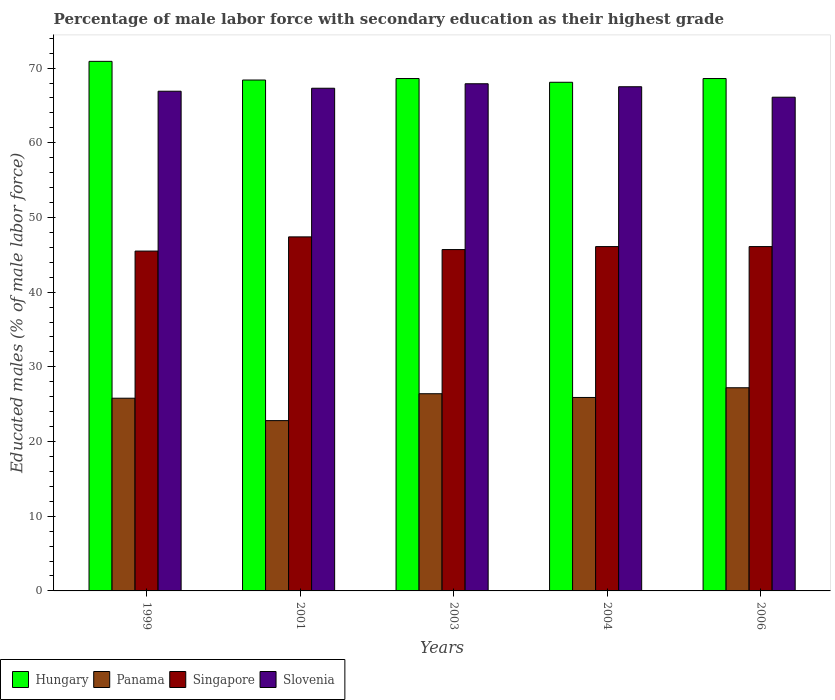How many groups of bars are there?
Keep it short and to the point. 5. Are the number of bars on each tick of the X-axis equal?
Offer a very short reply. Yes. How many bars are there on the 4th tick from the right?
Keep it short and to the point. 4. In how many cases, is the number of bars for a given year not equal to the number of legend labels?
Your answer should be compact. 0. What is the percentage of male labor force with secondary education in Panama in 2001?
Your response must be concise. 22.8. Across all years, what is the maximum percentage of male labor force with secondary education in Hungary?
Ensure brevity in your answer.  70.9. Across all years, what is the minimum percentage of male labor force with secondary education in Singapore?
Provide a succinct answer. 45.5. What is the total percentage of male labor force with secondary education in Singapore in the graph?
Keep it short and to the point. 230.8. What is the difference between the percentage of male labor force with secondary education in Panama in 2001 and that in 2004?
Your response must be concise. -3.1. What is the difference between the percentage of male labor force with secondary education in Slovenia in 1999 and the percentage of male labor force with secondary education in Hungary in 2004?
Give a very brief answer. -1.2. What is the average percentage of male labor force with secondary education in Hungary per year?
Ensure brevity in your answer.  68.92. In the year 2004, what is the difference between the percentage of male labor force with secondary education in Panama and percentage of male labor force with secondary education in Hungary?
Give a very brief answer. -42.2. In how many years, is the percentage of male labor force with secondary education in Panama greater than 18 %?
Provide a short and direct response. 5. What is the ratio of the percentage of male labor force with secondary education in Slovenia in 2004 to that in 2006?
Make the answer very short. 1.02. What is the difference between the highest and the second highest percentage of male labor force with secondary education in Slovenia?
Provide a short and direct response. 0.4. What is the difference between the highest and the lowest percentage of male labor force with secondary education in Hungary?
Give a very brief answer. 2.8. In how many years, is the percentage of male labor force with secondary education in Hungary greater than the average percentage of male labor force with secondary education in Hungary taken over all years?
Make the answer very short. 1. Is the sum of the percentage of male labor force with secondary education in Hungary in 1999 and 2006 greater than the maximum percentage of male labor force with secondary education in Singapore across all years?
Make the answer very short. Yes. What does the 1st bar from the left in 2003 represents?
Your response must be concise. Hungary. What does the 3rd bar from the right in 2003 represents?
Offer a very short reply. Panama. Is it the case that in every year, the sum of the percentage of male labor force with secondary education in Panama and percentage of male labor force with secondary education in Singapore is greater than the percentage of male labor force with secondary education in Slovenia?
Provide a succinct answer. Yes. How many bars are there?
Provide a short and direct response. 20. Are all the bars in the graph horizontal?
Your answer should be compact. No. How many years are there in the graph?
Offer a very short reply. 5. Does the graph contain any zero values?
Your response must be concise. No. Where does the legend appear in the graph?
Offer a very short reply. Bottom left. What is the title of the graph?
Offer a terse response. Percentage of male labor force with secondary education as their highest grade. What is the label or title of the Y-axis?
Your answer should be very brief. Educated males (% of male labor force). What is the Educated males (% of male labor force) of Hungary in 1999?
Ensure brevity in your answer.  70.9. What is the Educated males (% of male labor force) in Panama in 1999?
Offer a terse response. 25.8. What is the Educated males (% of male labor force) in Singapore in 1999?
Offer a terse response. 45.5. What is the Educated males (% of male labor force) in Slovenia in 1999?
Make the answer very short. 66.9. What is the Educated males (% of male labor force) of Hungary in 2001?
Offer a very short reply. 68.4. What is the Educated males (% of male labor force) in Panama in 2001?
Give a very brief answer. 22.8. What is the Educated males (% of male labor force) in Singapore in 2001?
Offer a terse response. 47.4. What is the Educated males (% of male labor force) in Slovenia in 2001?
Keep it short and to the point. 67.3. What is the Educated males (% of male labor force) in Hungary in 2003?
Your answer should be compact. 68.6. What is the Educated males (% of male labor force) in Panama in 2003?
Your response must be concise. 26.4. What is the Educated males (% of male labor force) of Singapore in 2003?
Give a very brief answer. 45.7. What is the Educated males (% of male labor force) in Slovenia in 2003?
Provide a short and direct response. 67.9. What is the Educated males (% of male labor force) in Hungary in 2004?
Your answer should be very brief. 68.1. What is the Educated males (% of male labor force) in Panama in 2004?
Give a very brief answer. 25.9. What is the Educated males (% of male labor force) in Singapore in 2004?
Provide a succinct answer. 46.1. What is the Educated males (% of male labor force) in Slovenia in 2004?
Provide a short and direct response. 67.5. What is the Educated males (% of male labor force) in Hungary in 2006?
Offer a very short reply. 68.6. What is the Educated males (% of male labor force) in Panama in 2006?
Offer a terse response. 27.2. What is the Educated males (% of male labor force) in Singapore in 2006?
Your answer should be compact. 46.1. What is the Educated males (% of male labor force) in Slovenia in 2006?
Your response must be concise. 66.1. Across all years, what is the maximum Educated males (% of male labor force) of Hungary?
Provide a succinct answer. 70.9. Across all years, what is the maximum Educated males (% of male labor force) in Panama?
Provide a short and direct response. 27.2. Across all years, what is the maximum Educated males (% of male labor force) in Singapore?
Offer a very short reply. 47.4. Across all years, what is the maximum Educated males (% of male labor force) of Slovenia?
Provide a short and direct response. 67.9. Across all years, what is the minimum Educated males (% of male labor force) of Hungary?
Your answer should be very brief. 68.1. Across all years, what is the minimum Educated males (% of male labor force) of Panama?
Provide a short and direct response. 22.8. Across all years, what is the minimum Educated males (% of male labor force) in Singapore?
Ensure brevity in your answer.  45.5. Across all years, what is the minimum Educated males (% of male labor force) of Slovenia?
Offer a terse response. 66.1. What is the total Educated males (% of male labor force) of Hungary in the graph?
Your answer should be compact. 344.6. What is the total Educated males (% of male labor force) in Panama in the graph?
Your answer should be very brief. 128.1. What is the total Educated males (% of male labor force) of Singapore in the graph?
Ensure brevity in your answer.  230.8. What is the total Educated males (% of male labor force) in Slovenia in the graph?
Keep it short and to the point. 335.7. What is the difference between the Educated males (% of male labor force) of Hungary in 1999 and that in 2001?
Your response must be concise. 2.5. What is the difference between the Educated males (% of male labor force) in Singapore in 1999 and that in 2001?
Your response must be concise. -1.9. What is the difference between the Educated males (% of male labor force) in Panama in 1999 and that in 2003?
Your answer should be very brief. -0.6. What is the difference between the Educated males (% of male labor force) in Singapore in 1999 and that in 2003?
Give a very brief answer. -0.2. What is the difference between the Educated males (% of male labor force) of Hungary in 1999 and that in 2004?
Provide a short and direct response. 2.8. What is the difference between the Educated males (% of male labor force) of Panama in 1999 and that in 2004?
Offer a very short reply. -0.1. What is the difference between the Educated males (% of male labor force) of Panama in 1999 and that in 2006?
Keep it short and to the point. -1.4. What is the difference between the Educated males (% of male labor force) of Singapore in 1999 and that in 2006?
Your answer should be very brief. -0.6. What is the difference between the Educated males (% of male labor force) in Slovenia in 1999 and that in 2006?
Ensure brevity in your answer.  0.8. What is the difference between the Educated males (% of male labor force) of Panama in 2001 and that in 2003?
Give a very brief answer. -3.6. What is the difference between the Educated males (% of male labor force) in Singapore in 2001 and that in 2003?
Offer a very short reply. 1.7. What is the difference between the Educated males (% of male labor force) in Panama in 2001 and that in 2004?
Make the answer very short. -3.1. What is the difference between the Educated males (% of male labor force) in Singapore in 2001 and that in 2004?
Provide a short and direct response. 1.3. What is the difference between the Educated males (% of male labor force) of Slovenia in 2001 and that in 2004?
Make the answer very short. -0.2. What is the difference between the Educated males (% of male labor force) in Hungary in 2001 and that in 2006?
Your response must be concise. -0.2. What is the difference between the Educated males (% of male labor force) in Panama in 2001 and that in 2006?
Your answer should be compact. -4.4. What is the difference between the Educated males (% of male labor force) of Slovenia in 2001 and that in 2006?
Provide a succinct answer. 1.2. What is the difference between the Educated males (% of male labor force) in Panama in 2003 and that in 2004?
Your response must be concise. 0.5. What is the difference between the Educated males (% of male labor force) of Singapore in 2003 and that in 2004?
Your answer should be compact. -0.4. What is the difference between the Educated males (% of male labor force) in Panama in 2003 and that in 2006?
Offer a very short reply. -0.8. What is the difference between the Educated males (% of male labor force) of Singapore in 2003 and that in 2006?
Your response must be concise. -0.4. What is the difference between the Educated males (% of male labor force) of Slovenia in 2003 and that in 2006?
Your answer should be very brief. 1.8. What is the difference between the Educated males (% of male labor force) in Panama in 2004 and that in 2006?
Offer a very short reply. -1.3. What is the difference between the Educated males (% of male labor force) in Hungary in 1999 and the Educated males (% of male labor force) in Panama in 2001?
Provide a short and direct response. 48.1. What is the difference between the Educated males (% of male labor force) in Hungary in 1999 and the Educated males (% of male labor force) in Singapore in 2001?
Your answer should be very brief. 23.5. What is the difference between the Educated males (% of male labor force) of Hungary in 1999 and the Educated males (% of male labor force) of Slovenia in 2001?
Offer a terse response. 3.6. What is the difference between the Educated males (% of male labor force) in Panama in 1999 and the Educated males (% of male labor force) in Singapore in 2001?
Provide a succinct answer. -21.6. What is the difference between the Educated males (% of male labor force) of Panama in 1999 and the Educated males (% of male labor force) of Slovenia in 2001?
Your response must be concise. -41.5. What is the difference between the Educated males (% of male labor force) in Singapore in 1999 and the Educated males (% of male labor force) in Slovenia in 2001?
Your response must be concise. -21.8. What is the difference between the Educated males (% of male labor force) in Hungary in 1999 and the Educated males (% of male labor force) in Panama in 2003?
Your response must be concise. 44.5. What is the difference between the Educated males (% of male labor force) of Hungary in 1999 and the Educated males (% of male labor force) of Singapore in 2003?
Ensure brevity in your answer.  25.2. What is the difference between the Educated males (% of male labor force) of Hungary in 1999 and the Educated males (% of male labor force) of Slovenia in 2003?
Make the answer very short. 3. What is the difference between the Educated males (% of male labor force) in Panama in 1999 and the Educated males (% of male labor force) in Singapore in 2003?
Provide a short and direct response. -19.9. What is the difference between the Educated males (% of male labor force) in Panama in 1999 and the Educated males (% of male labor force) in Slovenia in 2003?
Your answer should be very brief. -42.1. What is the difference between the Educated males (% of male labor force) in Singapore in 1999 and the Educated males (% of male labor force) in Slovenia in 2003?
Keep it short and to the point. -22.4. What is the difference between the Educated males (% of male labor force) of Hungary in 1999 and the Educated males (% of male labor force) of Singapore in 2004?
Your answer should be very brief. 24.8. What is the difference between the Educated males (% of male labor force) of Hungary in 1999 and the Educated males (% of male labor force) of Slovenia in 2004?
Give a very brief answer. 3.4. What is the difference between the Educated males (% of male labor force) of Panama in 1999 and the Educated males (% of male labor force) of Singapore in 2004?
Offer a very short reply. -20.3. What is the difference between the Educated males (% of male labor force) in Panama in 1999 and the Educated males (% of male labor force) in Slovenia in 2004?
Give a very brief answer. -41.7. What is the difference between the Educated males (% of male labor force) of Singapore in 1999 and the Educated males (% of male labor force) of Slovenia in 2004?
Ensure brevity in your answer.  -22. What is the difference between the Educated males (% of male labor force) of Hungary in 1999 and the Educated males (% of male labor force) of Panama in 2006?
Provide a short and direct response. 43.7. What is the difference between the Educated males (% of male labor force) of Hungary in 1999 and the Educated males (% of male labor force) of Singapore in 2006?
Offer a terse response. 24.8. What is the difference between the Educated males (% of male labor force) of Panama in 1999 and the Educated males (% of male labor force) of Singapore in 2006?
Offer a very short reply. -20.3. What is the difference between the Educated males (% of male labor force) of Panama in 1999 and the Educated males (% of male labor force) of Slovenia in 2006?
Keep it short and to the point. -40.3. What is the difference between the Educated males (% of male labor force) of Singapore in 1999 and the Educated males (% of male labor force) of Slovenia in 2006?
Provide a succinct answer. -20.6. What is the difference between the Educated males (% of male labor force) in Hungary in 2001 and the Educated males (% of male labor force) in Panama in 2003?
Your answer should be compact. 42. What is the difference between the Educated males (% of male labor force) of Hungary in 2001 and the Educated males (% of male labor force) of Singapore in 2003?
Your answer should be very brief. 22.7. What is the difference between the Educated males (% of male labor force) in Panama in 2001 and the Educated males (% of male labor force) in Singapore in 2003?
Provide a short and direct response. -22.9. What is the difference between the Educated males (% of male labor force) in Panama in 2001 and the Educated males (% of male labor force) in Slovenia in 2003?
Your response must be concise. -45.1. What is the difference between the Educated males (% of male labor force) of Singapore in 2001 and the Educated males (% of male labor force) of Slovenia in 2003?
Provide a short and direct response. -20.5. What is the difference between the Educated males (% of male labor force) in Hungary in 2001 and the Educated males (% of male labor force) in Panama in 2004?
Provide a succinct answer. 42.5. What is the difference between the Educated males (% of male labor force) of Hungary in 2001 and the Educated males (% of male labor force) of Singapore in 2004?
Offer a very short reply. 22.3. What is the difference between the Educated males (% of male labor force) of Hungary in 2001 and the Educated males (% of male labor force) of Slovenia in 2004?
Provide a succinct answer. 0.9. What is the difference between the Educated males (% of male labor force) in Panama in 2001 and the Educated males (% of male labor force) in Singapore in 2004?
Your answer should be compact. -23.3. What is the difference between the Educated males (% of male labor force) in Panama in 2001 and the Educated males (% of male labor force) in Slovenia in 2004?
Your answer should be compact. -44.7. What is the difference between the Educated males (% of male labor force) in Singapore in 2001 and the Educated males (% of male labor force) in Slovenia in 2004?
Keep it short and to the point. -20.1. What is the difference between the Educated males (% of male labor force) of Hungary in 2001 and the Educated males (% of male labor force) of Panama in 2006?
Make the answer very short. 41.2. What is the difference between the Educated males (% of male labor force) of Hungary in 2001 and the Educated males (% of male labor force) of Singapore in 2006?
Ensure brevity in your answer.  22.3. What is the difference between the Educated males (% of male labor force) in Hungary in 2001 and the Educated males (% of male labor force) in Slovenia in 2006?
Your response must be concise. 2.3. What is the difference between the Educated males (% of male labor force) in Panama in 2001 and the Educated males (% of male labor force) in Singapore in 2006?
Provide a short and direct response. -23.3. What is the difference between the Educated males (% of male labor force) of Panama in 2001 and the Educated males (% of male labor force) of Slovenia in 2006?
Your response must be concise. -43.3. What is the difference between the Educated males (% of male labor force) in Singapore in 2001 and the Educated males (% of male labor force) in Slovenia in 2006?
Your answer should be very brief. -18.7. What is the difference between the Educated males (% of male labor force) of Hungary in 2003 and the Educated males (% of male labor force) of Panama in 2004?
Provide a short and direct response. 42.7. What is the difference between the Educated males (% of male labor force) of Hungary in 2003 and the Educated males (% of male labor force) of Singapore in 2004?
Your answer should be compact. 22.5. What is the difference between the Educated males (% of male labor force) in Panama in 2003 and the Educated males (% of male labor force) in Singapore in 2004?
Offer a terse response. -19.7. What is the difference between the Educated males (% of male labor force) in Panama in 2003 and the Educated males (% of male labor force) in Slovenia in 2004?
Ensure brevity in your answer.  -41.1. What is the difference between the Educated males (% of male labor force) in Singapore in 2003 and the Educated males (% of male labor force) in Slovenia in 2004?
Keep it short and to the point. -21.8. What is the difference between the Educated males (% of male labor force) in Hungary in 2003 and the Educated males (% of male labor force) in Panama in 2006?
Ensure brevity in your answer.  41.4. What is the difference between the Educated males (% of male labor force) in Hungary in 2003 and the Educated males (% of male labor force) in Singapore in 2006?
Your response must be concise. 22.5. What is the difference between the Educated males (% of male labor force) in Panama in 2003 and the Educated males (% of male labor force) in Singapore in 2006?
Offer a terse response. -19.7. What is the difference between the Educated males (% of male labor force) in Panama in 2003 and the Educated males (% of male labor force) in Slovenia in 2006?
Make the answer very short. -39.7. What is the difference between the Educated males (% of male labor force) in Singapore in 2003 and the Educated males (% of male labor force) in Slovenia in 2006?
Offer a terse response. -20.4. What is the difference between the Educated males (% of male labor force) of Hungary in 2004 and the Educated males (% of male labor force) of Panama in 2006?
Your response must be concise. 40.9. What is the difference between the Educated males (% of male labor force) in Panama in 2004 and the Educated males (% of male labor force) in Singapore in 2006?
Give a very brief answer. -20.2. What is the difference between the Educated males (% of male labor force) of Panama in 2004 and the Educated males (% of male labor force) of Slovenia in 2006?
Offer a very short reply. -40.2. What is the difference between the Educated males (% of male labor force) in Singapore in 2004 and the Educated males (% of male labor force) in Slovenia in 2006?
Offer a terse response. -20. What is the average Educated males (% of male labor force) of Hungary per year?
Provide a short and direct response. 68.92. What is the average Educated males (% of male labor force) in Panama per year?
Your response must be concise. 25.62. What is the average Educated males (% of male labor force) of Singapore per year?
Your answer should be very brief. 46.16. What is the average Educated males (% of male labor force) of Slovenia per year?
Your answer should be very brief. 67.14. In the year 1999, what is the difference between the Educated males (% of male labor force) in Hungary and Educated males (% of male labor force) in Panama?
Give a very brief answer. 45.1. In the year 1999, what is the difference between the Educated males (% of male labor force) in Hungary and Educated males (% of male labor force) in Singapore?
Ensure brevity in your answer.  25.4. In the year 1999, what is the difference between the Educated males (% of male labor force) in Panama and Educated males (% of male labor force) in Singapore?
Provide a short and direct response. -19.7. In the year 1999, what is the difference between the Educated males (% of male labor force) in Panama and Educated males (% of male labor force) in Slovenia?
Ensure brevity in your answer.  -41.1. In the year 1999, what is the difference between the Educated males (% of male labor force) of Singapore and Educated males (% of male labor force) of Slovenia?
Provide a succinct answer. -21.4. In the year 2001, what is the difference between the Educated males (% of male labor force) in Hungary and Educated males (% of male labor force) in Panama?
Ensure brevity in your answer.  45.6. In the year 2001, what is the difference between the Educated males (% of male labor force) in Panama and Educated males (% of male labor force) in Singapore?
Ensure brevity in your answer.  -24.6. In the year 2001, what is the difference between the Educated males (% of male labor force) of Panama and Educated males (% of male labor force) of Slovenia?
Provide a short and direct response. -44.5. In the year 2001, what is the difference between the Educated males (% of male labor force) in Singapore and Educated males (% of male labor force) in Slovenia?
Offer a very short reply. -19.9. In the year 2003, what is the difference between the Educated males (% of male labor force) in Hungary and Educated males (% of male labor force) in Panama?
Offer a very short reply. 42.2. In the year 2003, what is the difference between the Educated males (% of male labor force) of Hungary and Educated males (% of male labor force) of Singapore?
Provide a short and direct response. 22.9. In the year 2003, what is the difference between the Educated males (% of male labor force) of Hungary and Educated males (% of male labor force) of Slovenia?
Provide a short and direct response. 0.7. In the year 2003, what is the difference between the Educated males (% of male labor force) in Panama and Educated males (% of male labor force) in Singapore?
Offer a terse response. -19.3. In the year 2003, what is the difference between the Educated males (% of male labor force) in Panama and Educated males (% of male labor force) in Slovenia?
Offer a terse response. -41.5. In the year 2003, what is the difference between the Educated males (% of male labor force) of Singapore and Educated males (% of male labor force) of Slovenia?
Ensure brevity in your answer.  -22.2. In the year 2004, what is the difference between the Educated males (% of male labor force) in Hungary and Educated males (% of male labor force) in Panama?
Keep it short and to the point. 42.2. In the year 2004, what is the difference between the Educated males (% of male labor force) in Hungary and Educated males (% of male labor force) in Singapore?
Make the answer very short. 22. In the year 2004, what is the difference between the Educated males (% of male labor force) in Hungary and Educated males (% of male labor force) in Slovenia?
Provide a short and direct response. 0.6. In the year 2004, what is the difference between the Educated males (% of male labor force) of Panama and Educated males (% of male labor force) of Singapore?
Give a very brief answer. -20.2. In the year 2004, what is the difference between the Educated males (% of male labor force) of Panama and Educated males (% of male labor force) of Slovenia?
Offer a very short reply. -41.6. In the year 2004, what is the difference between the Educated males (% of male labor force) in Singapore and Educated males (% of male labor force) in Slovenia?
Offer a terse response. -21.4. In the year 2006, what is the difference between the Educated males (% of male labor force) of Hungary and Educated males (% of male labor force) of Panama?
Make the answer very short. 41.4. In the year 2006, what is the difference between the Educated males (% of male labor force) of Panama and Educated males (% of male labor force) of Singapore?
Offer a very short reply. -18.9. In the year 2006, what is the difference between the Educated males (% of male labor force) of Panama and Educated males (% of male labor force) of Slovenia?
Your response must be concise. -38.9. What is the ratio of the Educated males (% of male labor force) in Hungary in 1999 to that in 2001?
Offer a very short reply. 1.04. What is the ratio of the Educated males (% of male labor force) in Panama in 1999 to that in 2001?
Your response must be concise. 1.13. What is the ratio of the Educated males (% of male labor force) of Singapore in 1999 to that in 2001?
Ensure brevity in your answer.  0.96. What is the ratio of the Educated males (% of male labor force) of Slovenia in 1999 to that in 2001?
Provide a succinct answer. 0.99. What is the ratio of the Educated males (% of male labor force) of Hungary in 1999 to that in 2003?
Your answer should be very brief. 1.03. What is the ratio of the Educated males (% of male labor force) in Panama in 1999 to that in 2003?
Give a very brief answer. 0.98. What is the ratio of the Educated males (% of male labor force) of Slovenia in 1999 to that in 2003?
Provide a short and direct response. 0.99. What is the ratio of the Educated males (% of male labor force) in Hungary in 1999 to that in 2004?
Keep it short and to the point. 1.04. What is the ratio of the Educated males (% of male labor force) of Panama in 1999 to that in 2004?
Your answer should be compact. 1. What is the ratio of the Educated males (% of male labor force) in Hungary in 1999 to that in 2006?
Ensure brevity in your answer.  1.03. What is the ratio of the Educated males (% of male labor force) of Panama in 1999 to that in 2006?
Your response must be concise. 0.95. What is the ratio of the Educated males (% of male labor force) of Slovenia in 1999 to that in 2006?
Make the answer very short. 1.01. What is the ratio of the Educated males (% of male labor force) in Hungary in 2001 to that in 2003?
Provide a succinct answer. 1. What is the ratio of the Educated males (% of male labor force) in Panama in 2001 to that in 2003?
Offer a very short reply. 0.86. What is the ratio of the Educated males (% of male labor force) of Singapore in 2001 to that in 2003?
Ensure brevity in your answer.  1.04. What is the ratio of the Educated males (% of male labor force) in Panama in 2001 to that in 2004?
Offer a terse response. 0.88. What is the ratio of the Educated males (% of male labor force) in Singapore in 2001 to that in 2004?
Offer a terse response. 1.03. What is the ratio of the Educated males (% of male labor force) in Slovenia in 2001 to that in 2004?
Your answer should be compact. 1. What is the ratio of the Educated males (% of male labor force) in Hungary in 2001 to that in 2006?
Keep it short and to the point. 1. What is the ratio of the Educated males (% of male labor force) of Panama in 2001 to that in 2006?
Your answer should be very brief. 0.84. What is the ratio of the Educated males (% of male labor force) of Singapore in 2001 to that in 2006?
Your answer should be compact. 1.03. What is the ratio of the Educated males (% of male labor force) in Slovenia in 2001 to that in 2006?
Make the answer very short. 1.02. What is the ratio of the Educated males (% of male labor force) in Hungary in 2003 to that in 2004?
Your answer should be compact. 1.01. What is the ratio of the Educated males (% of male labor force) of Panama in 2003 to that in 2004?
Give a very brief answer. 1.02. What is the ratio of the Educated males (% of male labor force) of Singapore in 2003 to that in 2004?
Ensure brevity in your answer.  0.99. What is the ratio of the Educated males (% of male labor force) in Slovenia in 2003 to that in 2004?
Make the answer very short. 1.01. What is the ratio of the Educated males (% of male labor force) in Panama in 2003 to that in 2006?
Offer a very short reply. 0.97. What is the ratio of the Educated males (% of male labor force) of Slovenia in 2003 to that in 2006?
Provide a short and direct response. 1.03. What is the ratio of the Educated males (% of male labor force) in Panama in 2004 to that in 2006?
Provide a succinct answer. 0.95. What is the ratio of the Educated males (% of male labor force) in Singapore in 2004 to that in 2006?
Keep it short and to the point. 1. What is the ratio of the Educated males (% of male labor force) of Slovenia in 2004 to that in 2006?
Your answer should be very brief. 1.02. What is the difference between the highest and the second highest Educated males (% of male labor force) of Panama?
Give a very brief answer. 0.8. What is the difference between the highest and the second highest Educated males (% of male labor force) of Slovenia?
Keep it short and to the point. 0.4. What is the difference between the highest and the lowest Educated males (% of male labor force) of Hungary?
Your answer should be compact. 2.8. What is the difference between the highest and the lowest Educated males (% of male labor force) of Singapore?
Provide a short and direct response. 1.9. What is the difference between the highest and the lowest Educated males (% of male labor force) in Slovenia?
Keep it short and to the point. 1.8. 